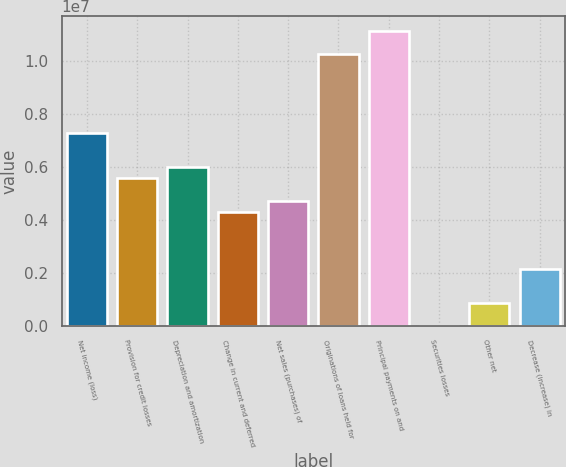<chart> <loc_0><loc_0><loc_500><loc_500><bar_chart><fcel>Net income (loss)<fcel>Provision for credit losses<fcel>Depreciation and amortization<fcel>Change in current and deferred<fcel>Net sales (purchases) of<fcel>Originations of loans held for<fcel>Principal payments on and<fcel>Securities losses<fcel>Other net<fcel>Decrease (increase) in<nl><fcel>7.28e+06<fcel>5.56792e+06<fcel>5.99594e+06<fcel>4.28387e+06<fcel>4.71188e+06<fcel>1.02761e+07<fcel>1.11322e+07<fcel>3681<fcel>859718<fcel>2.14377e+06<nl></chart> 